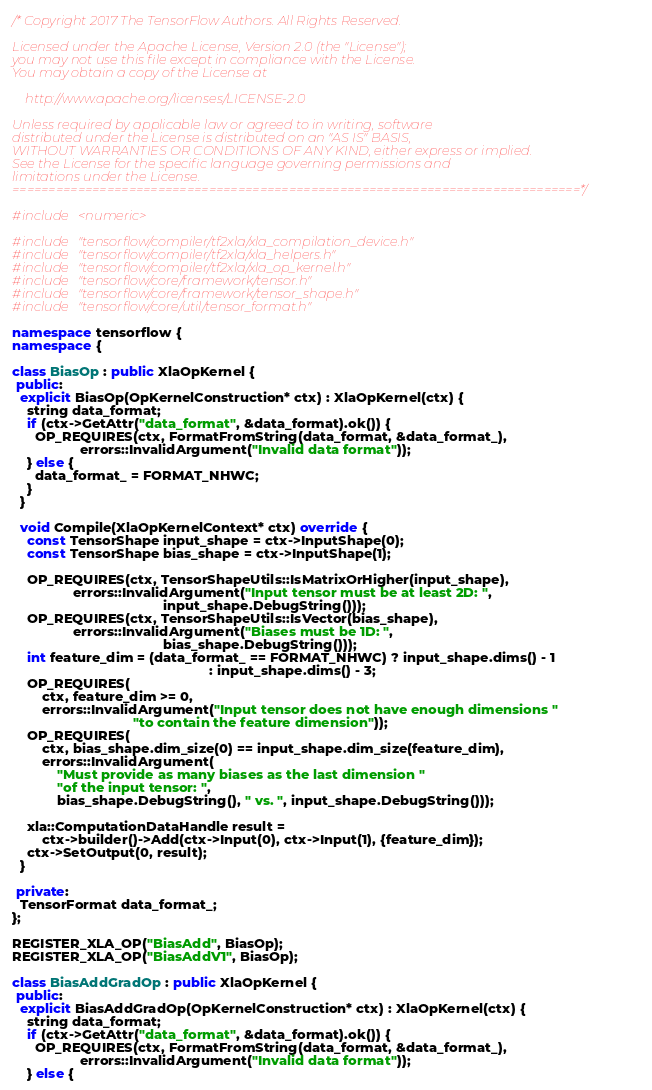Convert code to text. <code><loc_0><loc_0><loc_500><loc_500><_C++_>/* Copyright 2017 The TensorFlow Authors. All Rights Reserved.

Licensed under the Apache License, Version 2.0 (the "License");
you may not use this file except in compliance with the License.
You may obtain a copy of the License at

    http://www.apache.org/licenses/LICENSE-2.0

Unless required by applicable law or agreed to in writing, software
distributed under the License is distributed on an "AS IS" BASIS,
WITHOUT WARRANTIES OR CONDITIONS OF ANY KIND, either express or implied.
See the License for the specific language governing permissions and
limitations under the License.
==============================================================================*/

#include <numeric>

#include "tensorflow/compiler/tf2xla/xla_compilation_device.h"
#include "tensorflow/compiler/tf2xla/xla_helpers.h"
#include "tensorflow/compiler/tf2xla/xla_op_kernel.h"
#include "tensorflow/core/framework/tensor.h"
#include "tensorflow/core/framework/tensor_shape.h"
#include "tensorflow/core/util/tensor_format.h"

namespace tensorflow {
namespace {

class BiasOp : public XlaOpKernel {
 public:
  explicit BiasOp(OpKernelConstruction* ctx) : XlaOpKernel(ctx) {
    string data_format;
    if (ctx->GetAttr("data_format", &data_format).ok()) {
      OP_REQUIRES(ctx, FormatFromString(data_format, &data_format_),
                  errors::InvalidArgument("Invalid data format"));
    } else {
      data_format_ = FORMAT_NHWC;
    }
  }

  void Compile(XlaOpKernelContext* ctx) override {
    const TensorShape input_shape = ctx->InputShape(0);
    const TensorShape bias_shape = ctx->InputShape(1);

    OP_REQUIRES(ctx, TensorShapeUtils::IsMatrixOrHigher(input_shape),
                errors::InvalidArgument("Input tensor must be at least 2D: ",
                                        input_shape.DebugString()));
    OP_REQUIRES(ctx, TensorShapeUtils::IsVector(bias_shape),
                errors::InvalidArgument("Biases must be 1D: ",
                                        bias_shape.DebugString()));
    int feature_dim = (data_format_ == FORMAT_NHWC) ? input_shape.dims() - 1
                                                    : input_shape.dims() - 3;
    OP_REQUIRES(
        ctx, feature_dim >= 0,
        errors::InvalidArgument("Input tensor does not have enough dimensions "
                                "to contain the feature dimension"));
    OP_REQUIRES(
        ctx, bias_shape.dim_size(0) == input_shape.dim_size(feature_dim),
        errors::InvalidArgument(
            "Must provide as many biases as the last dimension "
            "of the input tensor: ",
            bias_shape.DebugString(), " vs. ", input_shape.DebugString()));

    xla::ComputationDataHandle result =
        ctx->builder()->Add(ctx->Input(0), ctx->Input(1), {feature_dim});
    ctx->SetOutput(0, result);
  }

 private:
  TensorFormat data_format_;
};

REGISTER_XLA_OP("BiasAdd", BiasOp);
REGISTER_XLA_OP("BiasAddV1", BiasOp);

class BiasAddGradOp : public XlaOpKernel {
 public:
  explicit BiasAddGradOp(OpKernelConstruction* ctx) : XlaOpKernel(ctx) {
    string data_format;
    if (ctx->GetAttr("data_format", &data_format).ok()) {
      OP_REQUIRES(ctx, FormatFromString(data_format, &data_format_),
                  errors::InvalidArgument("Invalid data format"));
    } else {</code> 